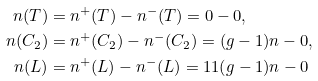<formula> <loc_0><loc_0><loc_500><loc_500>n ( T ) & = n ^ { + } ( T ) - n ^ { - } ( T ) = 0 - 0 , \\ n ( C _ { 2 } ) & = n ^ { + } ( C _ { 2 } ) - n ^ { - } ( C _ { 2 } ) = ( g - 1 ) n - 0 , \\ n ( L ) & = n ^ { + } ( L ) - n ^ { - } ( L ) = 1 1 ( g - 1 ) n - 0</formula> 